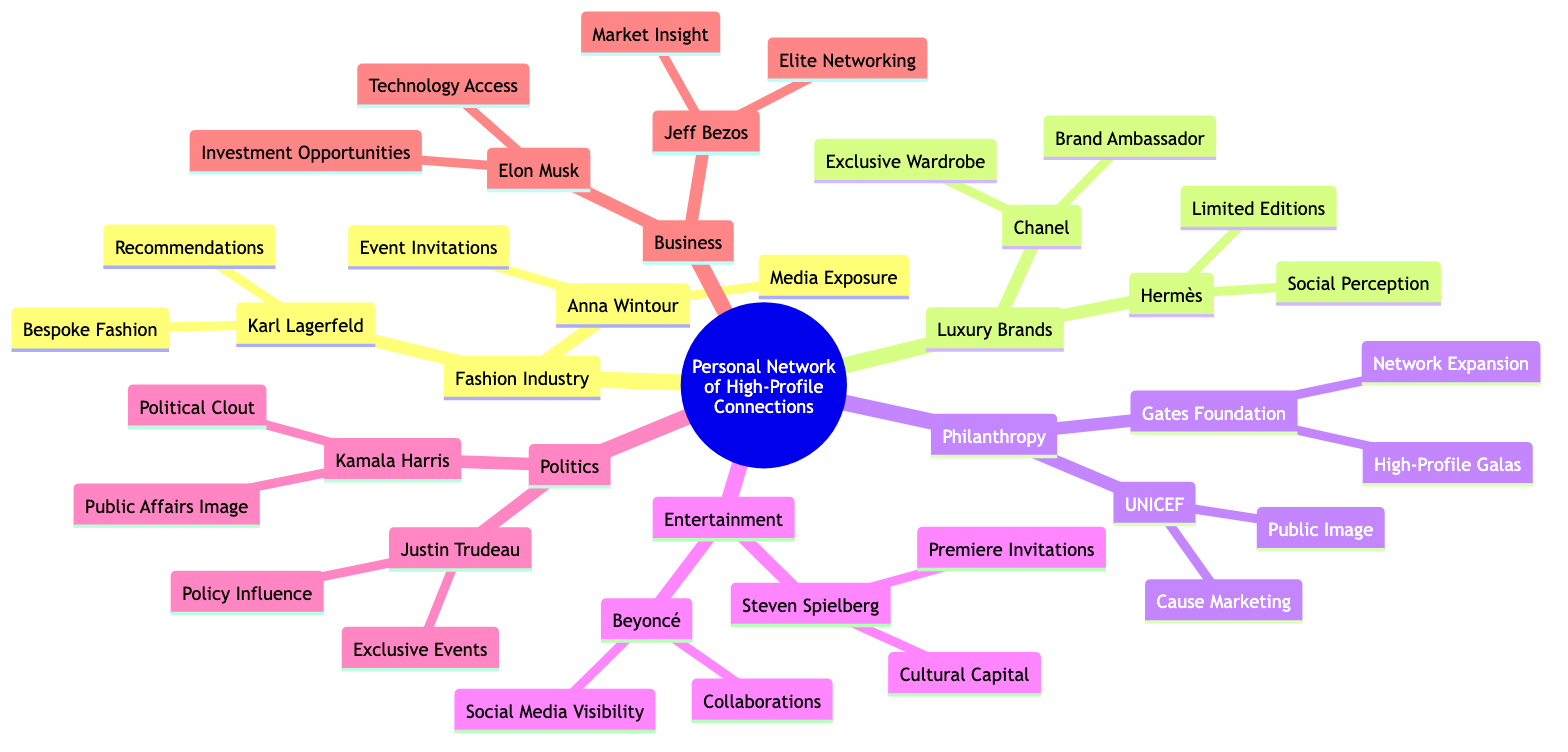What are the two main categories of connections in the diagram? The diagram is structured with a central node and several sub-nodes that categorize different types of high-profile connections, specifically "Fashion Industry" and "Luxury Brands" among others.
Answer: Fashion Industry, Luxury Brands Who influences public image enhancement in the Philanthropy node? Within the Philanthropic Circles, UNICEF is noted for enhancing public image, as indicated in the relationship between the organization and its described influence.
Answer: UNICEF How many connections are listed under the Entertainment Industry? The Entertainment Industry node includes two significant figures, Steven Spielberg and Beyoncé, which are explicitly listed in the diagram.
Answer: 2 Which luxury brand offers exclusive wardrobe opportunities? Chanel is identified in the Luxury Brand Associations node, where it explicitly states the influence of offering an exclusive wardrobe.
Answer: Chanel What is one way Elon Musk influences economic power? In the Business Magnates section, it states that Elon Musk provides "Technology Access" as part of his influence on economic power, showcasing a specific example of his impact.
Answer: Technology Access Which political figure is associated with exclusive event access? The Political Connections node specifies Justin Trudeau's influence as providing exclusive event access, clearly linking him with this privilege.
Answer: Justin Trudeau What role does Anna Wintour play in the Fashion Industry connections? The description under Anna Wintour in the Fashion Industry section indicates her role as the Editor-in-Chief of Vogue, providing a clear identification of her position within this network.
Answer: Editor-in-Chief of Vogue Which organization provides invitations to high-profile galas? The Bill and Melinda Gates Foundation is noted in the Philanthropic Circles for offering invitations to high-profile galas, marking this as a specific influence of the organization.
Answer: Bill and Melinda Gates Foundation What type of figure is Kamala Harris categorized as? Within the Political Connections, Kamala Harris is categorized as the Vice President of the United States, which highlights her specific role in that node.
Answer: Vice President of the United States 